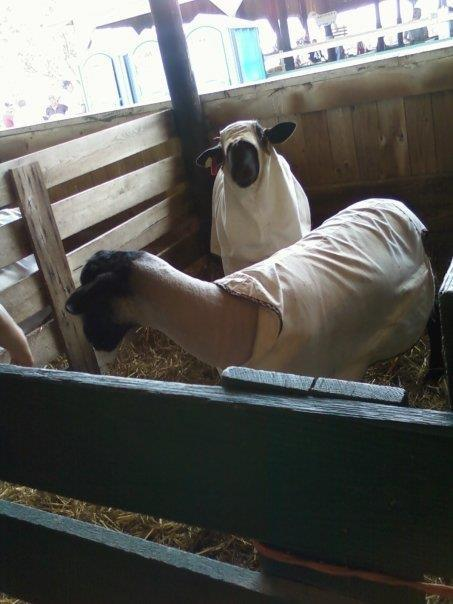What are the animals near?

Choices:
A) egg cartons
B) apples
C) tree
D) fence fence 